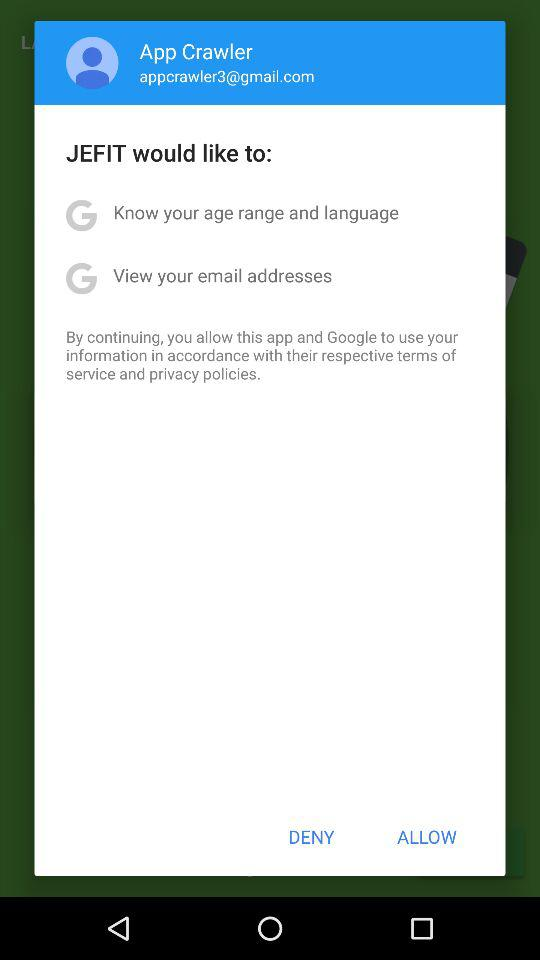How many items are there that JEFIT wants to access?
Answer the question using a single word or phrase. 2 